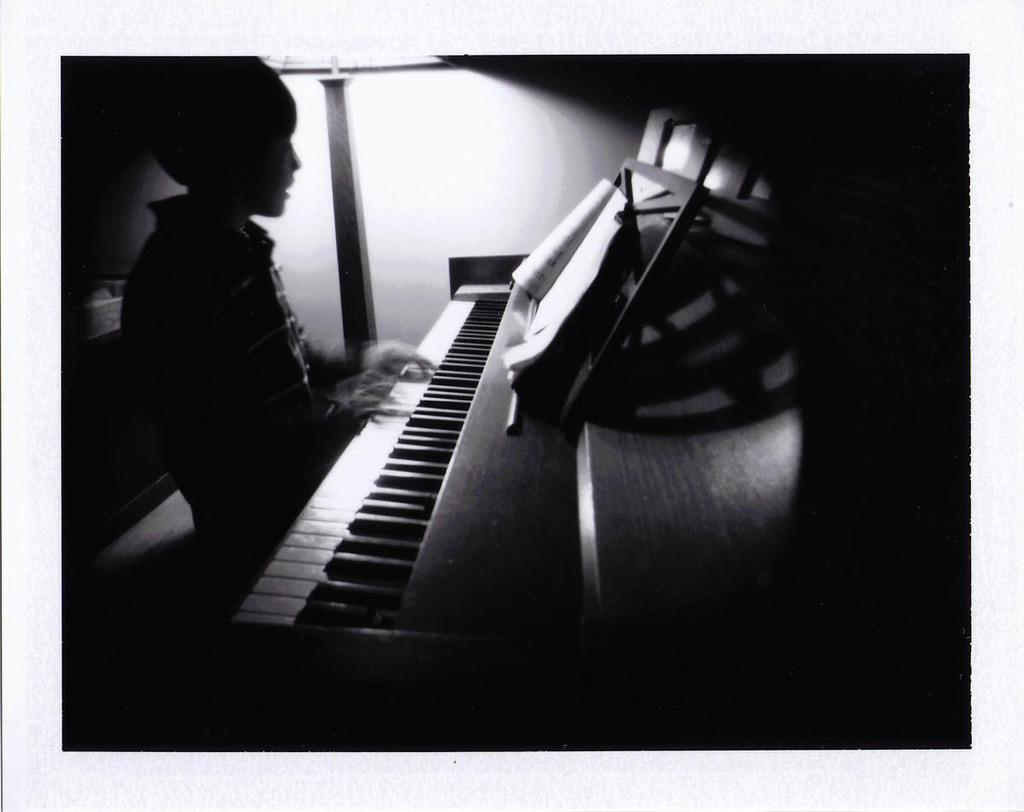Who is the main subject in the image? There is a boy in the image. What is the boy doing in the image? The boy is playing the piano. Where is the boy positioned in relation to the piano? The boy is sitting on the left side of the piano. What else can be seen on the piano? There is a book on the piano. What can be seen in the background of the image? There is a wall and a lamp in the background of the image. What is the rate of the waves crashing at the harbor in the image? There is no harbor or waves present in the image; it features a boy playing the piano. What type of school is depicted in the image? There is no school depicted in the image; it features a boy playing the piano with a book on it. 